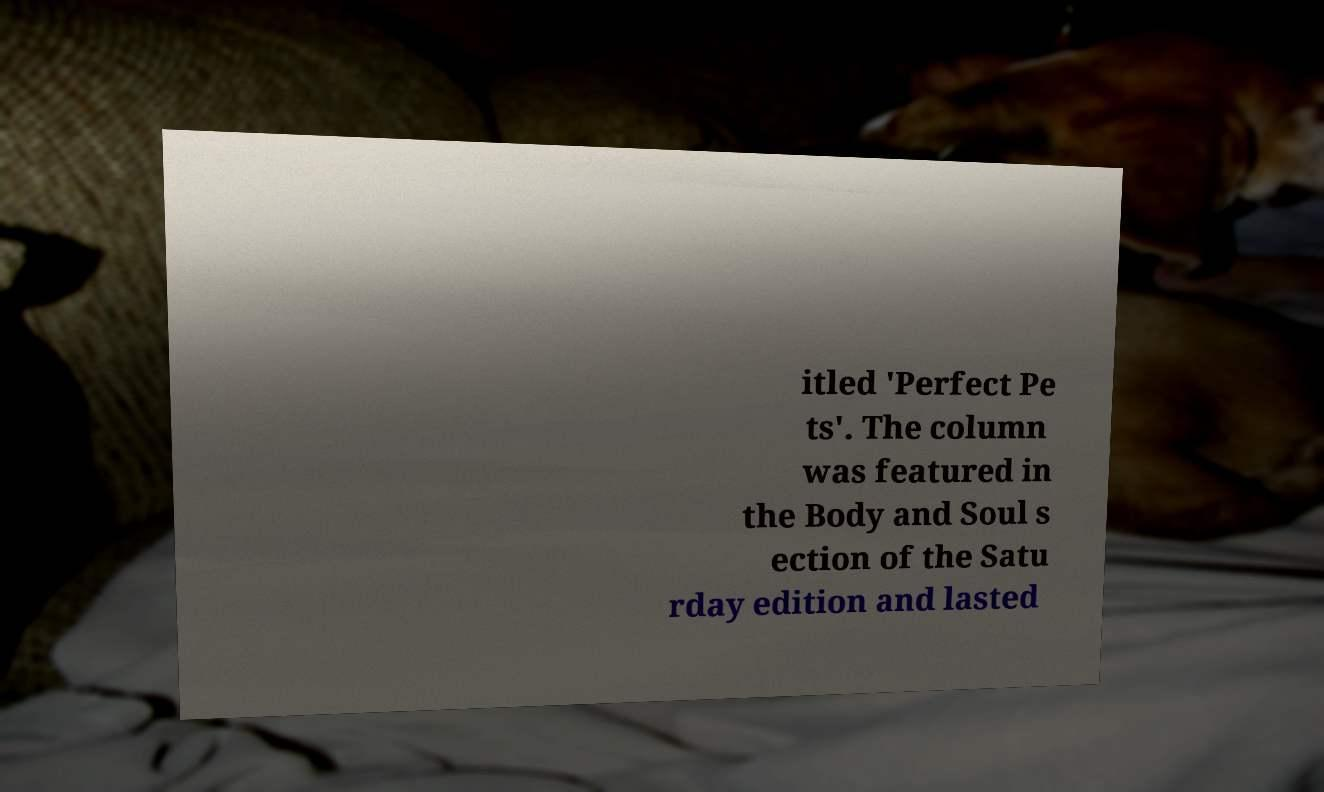Please identify and transcribe the text found in this image. itled 'Perfect Pe ts'. The column was featured in the Body and Soul s ection of the Satu rday edition and lasted 